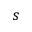<formula> <loc_0><loc_0><loc_500><loc_500>s</formula> 